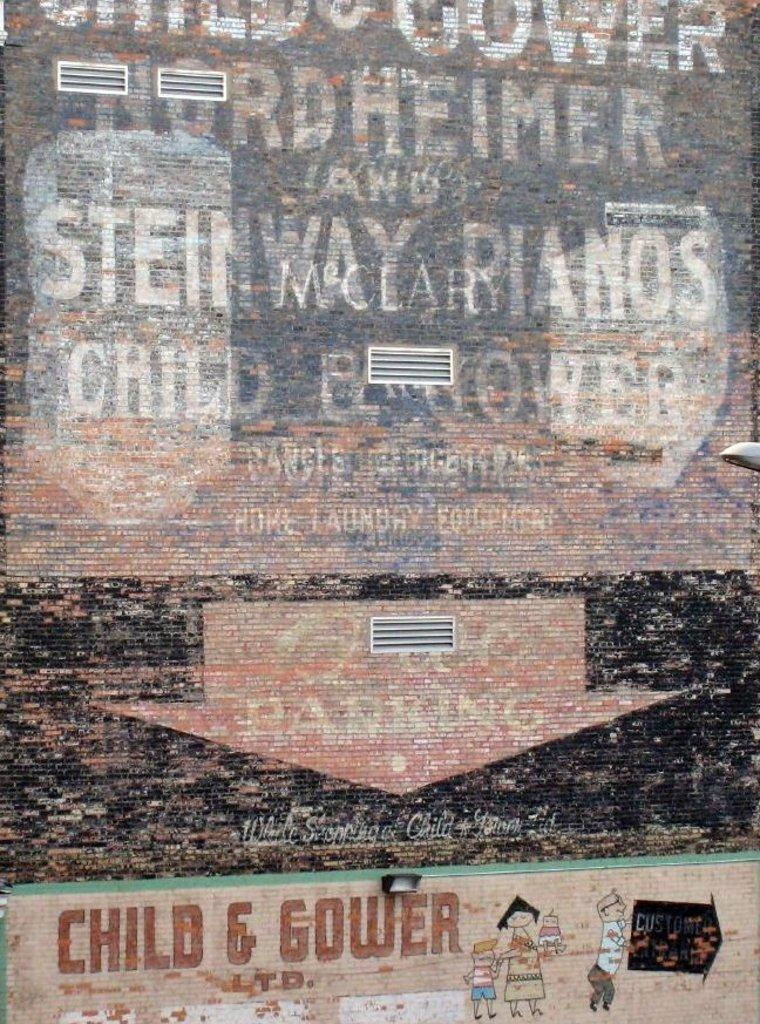<image>
Present a compact description of the photo's key features. A sign that states Child & Gower on the bottom of it 